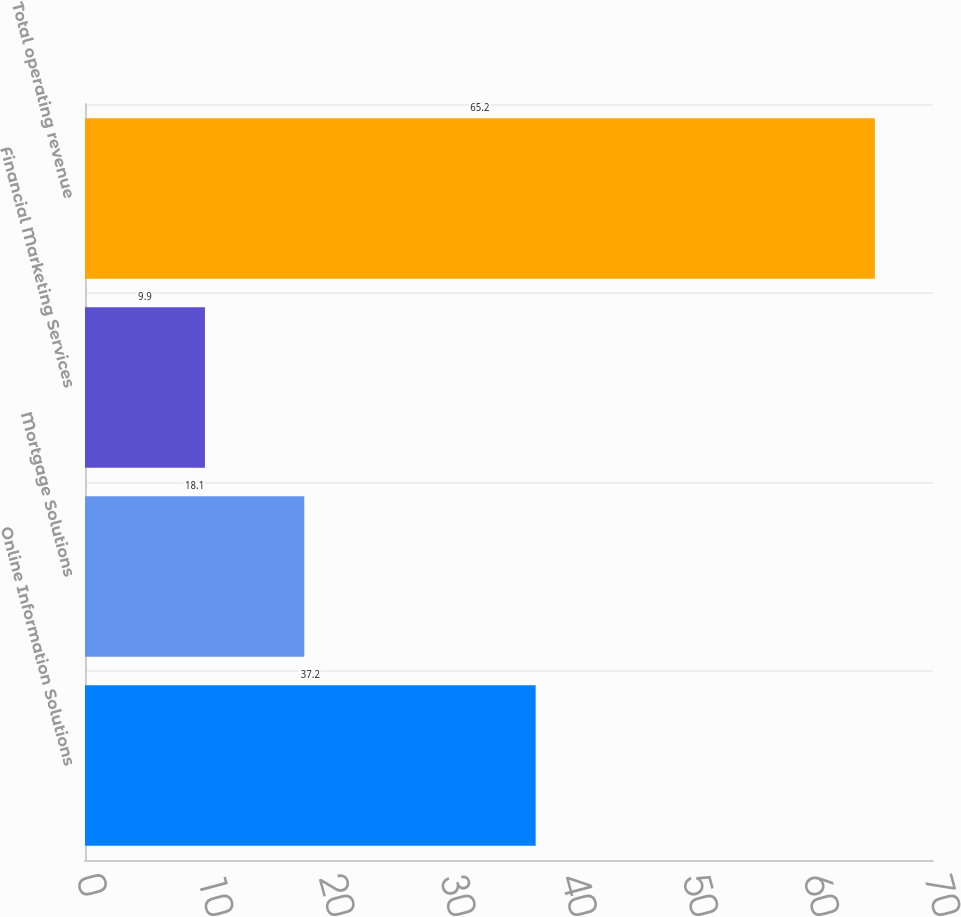Convert chart to OTSL. <chart><loc_0><loc_0><loc_500><loc_500><bar_chart><fcel>Online Information Solutions<fcel>Mortgage Solutions<fcel>Financial Marketing Services<fcel>Total operating revenue<nl><fcel>37.2<fcel>18.1<fcel>9.9<fcel>65.2<nl></chart> 